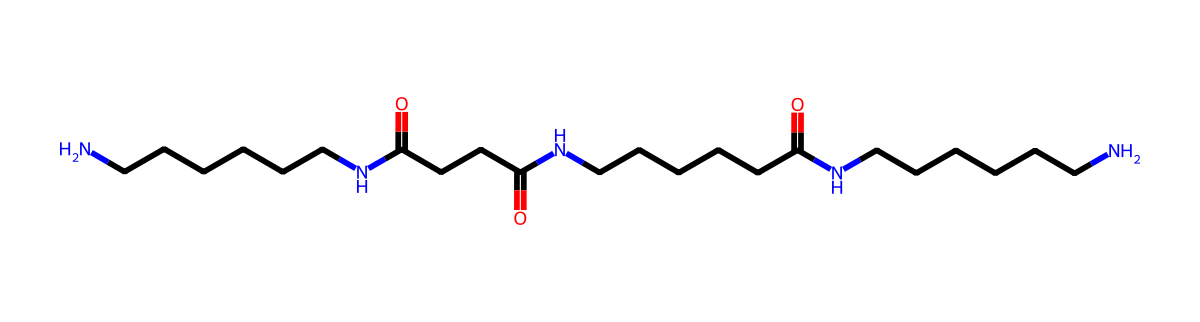What is the molecular formula of nylon-6,6 shown in this chemical structure? To determine the molecular formula from the SMILES representation, we need to count the number of each type of atom. In this case, there are 24 carbon (C) atoms, 42 hydrogen (H) atoms, and 6 nitrogen (N) atoms, which gives us the molecular formula C24H42N6.
Answer: C24H42N6 How many nitrogen atoms are present in this structure? By analyzing the SMILES representation, we count the number of nitrogen (N) symbols present. There are 6 instances of nitrogen atoms in the structure.
Answer: 6 What type of polymer is represented by this chemical structure? This SMILES depicts nylon-6,6, which is a type of polyamide due to the presence of amide bonds (-CONH-) linking the monomers together.
Answer: polyamide What is the total number of carbon atoms in the molecule? In the chemical structure, each carbon atom is represented by a 'C'. By counting the 'C' symbols in the SMILES representation, we find there are 24 carbon atoms.
Answer: 24 What property of nylon-6,6 contributes to its strength and durability when used in tote bags? Nylon-6,6 possesses strong intermolecular hydrogen bonding due to the amide groups, which contributes significantly to its tensile strength and durability. This strength is crucial for tote bags that are intended to carry heavy items.
Answer: hydrogen bonding What structural feature allows nylon-6,6 to be classified as a repeating unit in a polymer? The structure contains units that repeat along the backbone, specifically the segments that include carbon chains and amide linkages, which form the repeating pattern characteristic of polymers like nylon.
Answer: repeating units 